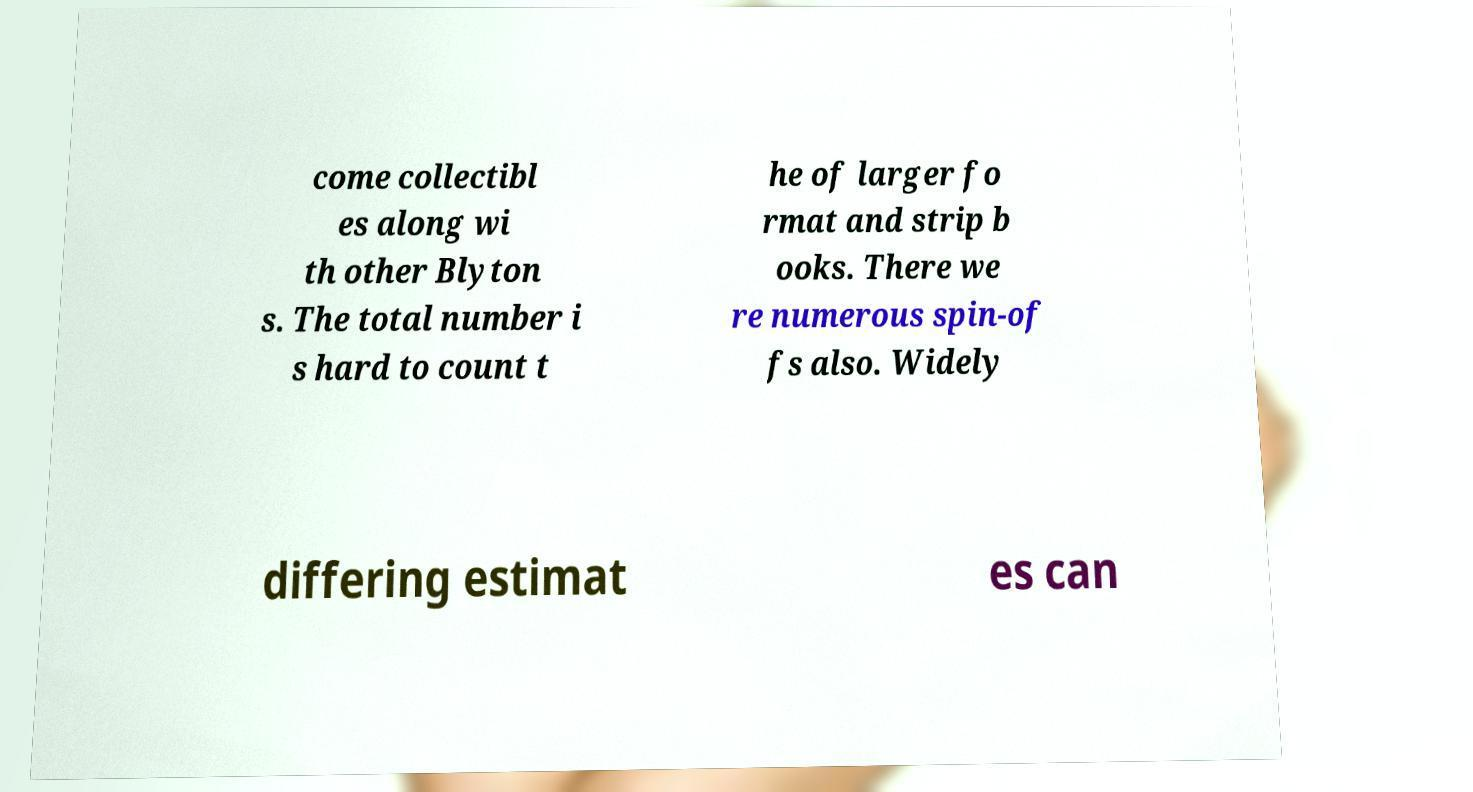For documentation purposes, I need the text within this image transcribed. Could you provide that? come collectibl es along wi th other Blyton s. The total number i s hard to count t he of larger fo rmat and strip b ooks. There we re numerous spin-of fs also. Widely differing estimat es can 